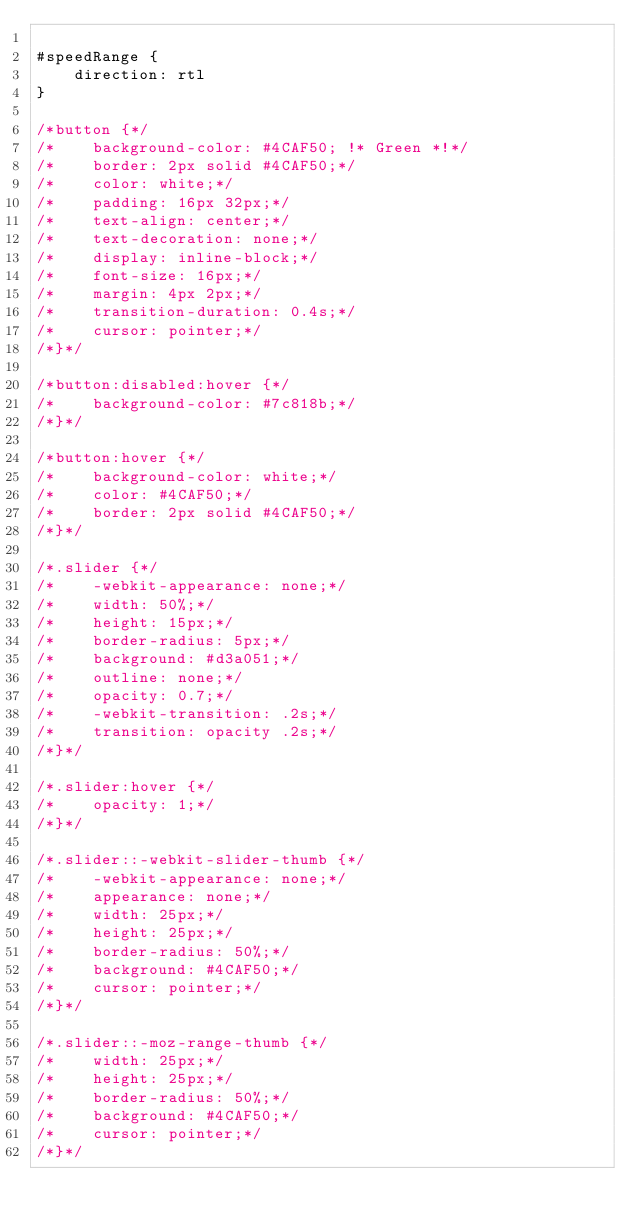<code> <loc_0><loc_0><loc_500><loc_500><_CSS_>
#speedRange {
    direction: rtl
}

/*button {*/
/*    background-color: #4CAF50; !* Green *!*/
/*    border: 2px solid #4CAF50;*/
/*    color: white;*/
/*    padding: 16px 32px;*/
/*    text-align: center;*/
/*    text-decoration: none;*/
/*    display: inline-block;*/
/*    font-size: 16px;*/
/*    margin: 4px 2px;*/
/*    transition-duration: 0.4s;*/
/*    cursor: pointer;*/
/*}*/

/*button:disabled:hover {*/
/*    background-color: #7c818b;*/
/*}*/

/*button:hover {*/
/*    background-color: white;*/
/*    color: #4CAF50;*/
/*    border: 2px solid #4CAF50;*/
/*}*/

/*.slider {*/
/*    -webkit-appearance: none;*/
/*    width: 50%;*/
/*    height: 15px;*/
/*    border-radius: 5px;*/
/*    background: #d3a051;*/
/*    outline: none;*/
/*    opacity: 0.7;*/
/*    -webkit-transition: .2s;*/
/*    transition: opacity .2s;*/
/*}*/

/*.slider:hover {*/
/*    opacity: 1;*/
/*}*/

/*.slider::-webkit-slider-thumb {*/
/*    -webkit-appearance: none;*/
/*    appearance: none;*/
/*    width: 25px;*/
/*    height: 25px;*/
/*    border-radius: 50%;*/
/*    background: #4CAF50;*/
/*    cursor: pointer;*/
/*}*/

/*.slider::-moz-range-thumb {*/
/*    width: 25px;*/
/*    height: 25px;*/
/*    border-radius: 50%;*/
/*    background: #4CAF50;*/
/*    cursor: pointer;*/
/*}*/
</code> 